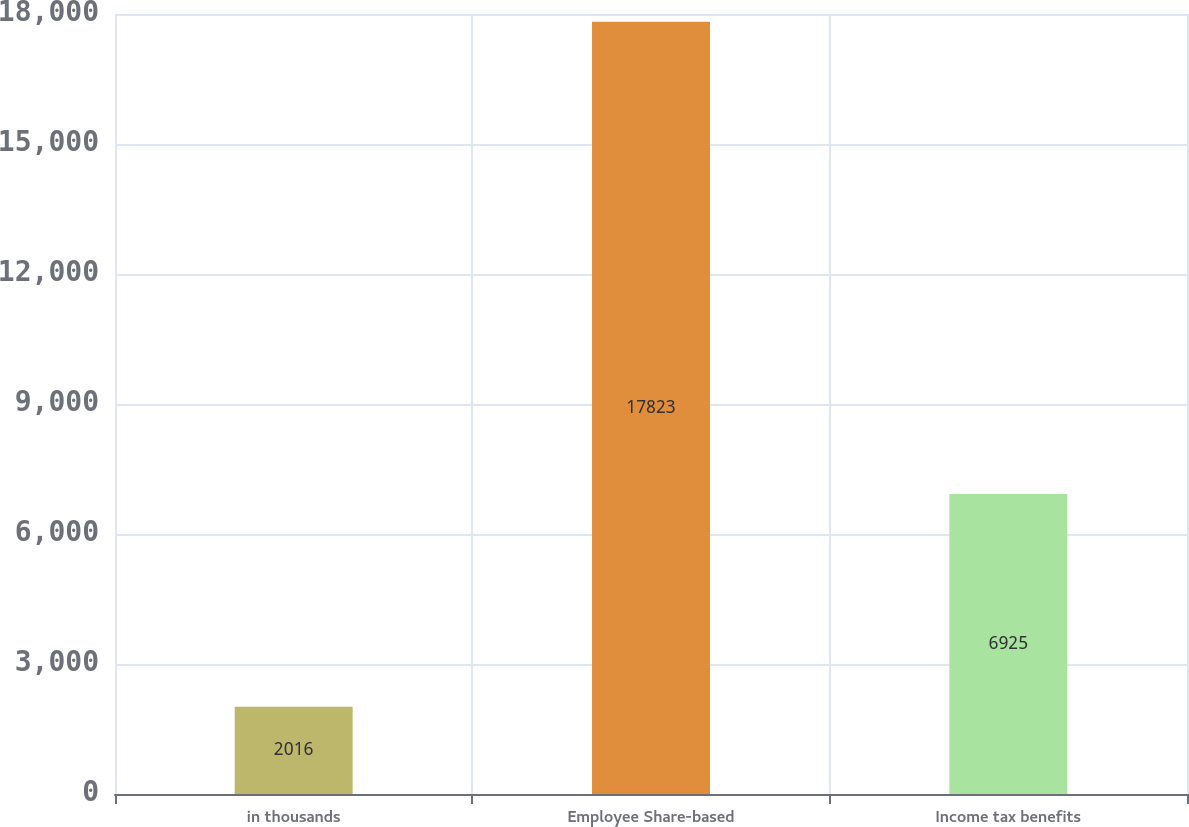<chart> <loc_0><loc_0><loc_500><loc_500><bar_chart><fcel>in thousands<fcel>Employee Share-based<fcel>Income tax benefits<nl><fcel>2016<fcel>17823<fcel>6925<nl></chart> 